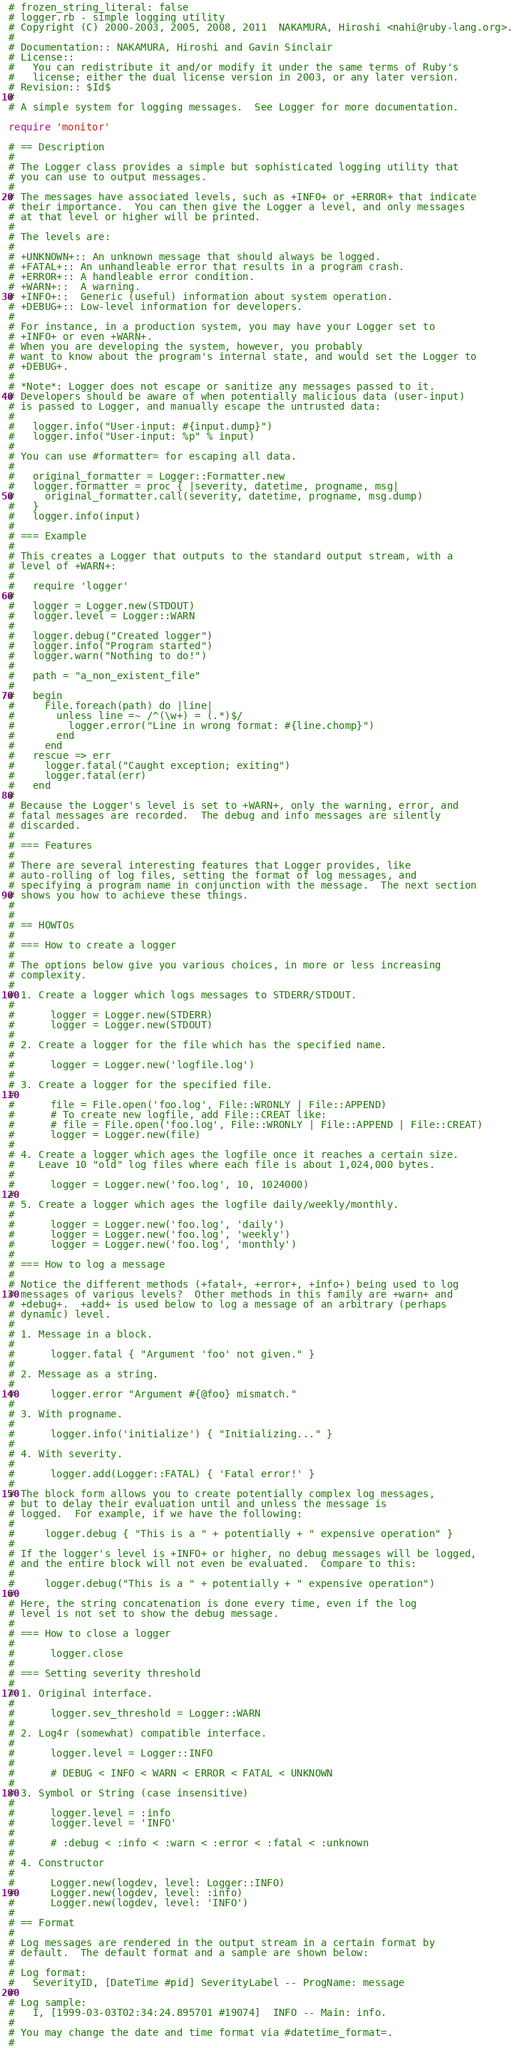<code> <loc_0><loc_0><loc_500><loc_500><_Ruby_># frozen_string_literal: false
# logger.rb - simple logging utility
# Copyright (C) 2000-2003, 2005, 2008, 2011  NAKAMURA, Hiroshi <nahi@ruby-lang.org>.
#
# Documentation:: NAKAMURA, Hiroshi and Gavin Sinclair
# License::
#   You can redistribute it and/or modify it under the same terms of Ruby's
#   license; either the dual license version in 2003, or any later version.
# Revision:: $Id$
#
# A simple system for logging messages.  See Logger for more documentation.

require 'monitor'

# == Description
#
# The Logger class provides a simple but sophisticated logging utility that
# you can use to output messages.
#
# The messages have associated levels, such as +INFO+ or +ERROR+ that indicate
# their importance.  You can then give the Logger a level, and only messages
# at that level or higher will be printed.
#
# The levels are:
#
# +UNKNOWN+:: An unknown message that should always be logged.
# +FATAL+:: An unhandleable error that results in a program crash.
# +ERROR+:: A handleable error condition.
# +WARN+::  A warning.
# +INFO+::  Generic (useful) information about system operation.
# +DEBUG+:: Low-level information for developers.
#
# For instance, in a production system, you may have your Logger set to
# +INFO+ or even +WARN+.
# When you are developing the system, however, you probably
# want to know about the program's internal state, and would set the Logger to
# +DEBUG+.
#
# *Note*: Logger does not escape or sanitize any messages passed to it.
# Developers should be aware of when potentially malicious data (user-input)
# is passed to Logger, and manually escape the untrusted data:
#
#   logger.info("User-input: #{input.dump}")
#   logger.info("User-input: %p" % input)
#
# You can use #formatter= for escaping all data.
#
#   original_formatter = Logger::Formatter.new
#   logger.formatter = proc { |severity, datetime, progname, msg|
#     original_formatter.call(severity, datetime, progname, msg.dump)
#   }
#   logger.info(input)
#
# === Example
#
# This creates a Logger that outputs to the standard output stream, with a
# level of +WARN+:
#
#   require 'logger'
#
#   logger = Logger.new(STDOUT)
#   logger.level = Logger::WARN
#
#   logger.debug("Created logger")
#   logger.info("Program started")
#   logger.warn("Nothing to do!")
#
#   path = "a_non_existent_file"
#
#   begin
#     File.foreach(path) do |line|
#       unless line =~ /^(\w+) = (.*)$/
#         logger.error("Line in wrong format: #{line.chomp}")
#       end
#     end
#   rescue => err
#     logger.fatal("Caught exception; exiting")
#     logger.fatal(err)
#   end
#
# Because the Logger's level is set to +WARN+, only the warning, error, and
# fatal messages are recorded.  The debug and info messages are silently
# discarded.
#
# === Features
#
# There are several interesting features that Logger provides, like
# auto-rolling of log files, setting the format of log messages, and
# specifying a program name in conjunction with the message.  The next section
# shows you how to achieve these things.
#
#
# == HOWTOs
#
# === How to create a logger
#
# The options below give you various choices, in more or less increasing
# complexity.
#
# 1. Create a logger which logs messages to STDERR/STDOUT.
#
#      logger = Logger.new(STDERR)
#      logger = Logger.new(STDOUT)
#
# 2. Create a logger for the file which has the specified name.
#
#      logger = Logger.new('logfile.log')
#
# 3. Create a logger for the specified file.
#
#      file = File.open('foo.log', File::WRONLY | File::APPEND)
#      # To create new logfile, add File::CREAT like:
#      # file = File.open('foo.log', File::WRONLY | File::APPEND | File::CREAT)
#      logger = Logger.new(file)
#
# 4. Create a logger which ages the logfile once it reaches a certain size.
#    Leave 10 "old" log files where each file is about 1,024,000 bytes.
#
#      logger = Logger.new('foo.log', 10, 1024000)
#
# 5. Create a logger which ages the logfile daily/weekly/monthly.
#
#      logger = Logger.new('foo.log', 'daily')
#      logger = Logger.new('foo.log', 'weekly')
#      logger = Logger.new('foo.log', 'monthly')
#
# === How to log a message
#
# Notice the different methods (+fatal+, +error+, +info+) being used to log
# messages of various levels?  Other methods in this family are +warn+ and
# +debug+.  +add+ is used below to log a message of an arbitrary (perhaps
# dynamic) level.
#
# 1. Message in a block.
#
#      logger.fatal { "Argument 'foo' not given." }
#
# 2. Message as a string.
#
#      logger.error "Argument #{@foo} mismatch."
#
# 3. With progname.
#
#      logger.info('initialize') { "Initializing..." }
#
# 4. With severity.
#
#      logger.add(Logger::FATAL) { 'Fatal error!' }
#
# The block form allows you to create potentially complex log messages,
# but to delay their evaluation until and unless the message is
# logged.  For example, if we have the following:
#
#     logger.debug { "This is a " + potentially + " expensive operation" }
#
# If the logger's level is +INFO+ or higher, no debug messages will be logged,
# and the entire block will not even be evaluated.  Compare to this:
#
#     logger.debug("This is a " + potentially + " expensive operation")
#
# Here, the string concatenation is done every time, even if the log
# level is not set to show the debug message.
#
# === How to close a logger
#
#      logger.close
#
# === Setting severity threshold
#
# 1. Original interface.
#
#      logger.sev_threshold = Logger::WARN
#
# 2. Log4r (somewhat) compatible interface.
#
#      logger.level = Logger::INFO
#
#      # DEBUG < INFO < WARN < ERROR < FATAL < UNKNOWN
#
# 3. Symbol or String (case insensitive)
#
#      logger.level = :info
#      logger.level = 'INFO'
#
#      # :debug < :info < :warn < :error < :fatal < :unknown
#
# 4. Constructor
#
#      Logger.new(logdev, level: Logger::INFO)
#      Logger.new(logdev, level: :info)
#      Logger.new(logdev, level: 'INFO')
#
# == Format
#
# Log messages are rendered in the output stream in a certain format by
# default.  The default format and a sample are shown below:
#
# Log format:
#   SeverityID, [DateTime #pid] SeverityLabel -- ProgName: message
#
# Log sample:
#   I, [1999-03-03T02:34:24.895701 #19074]  INFO -- Main: info.
#
# You may change the date and time format via #datetime_format=.
#</code> 